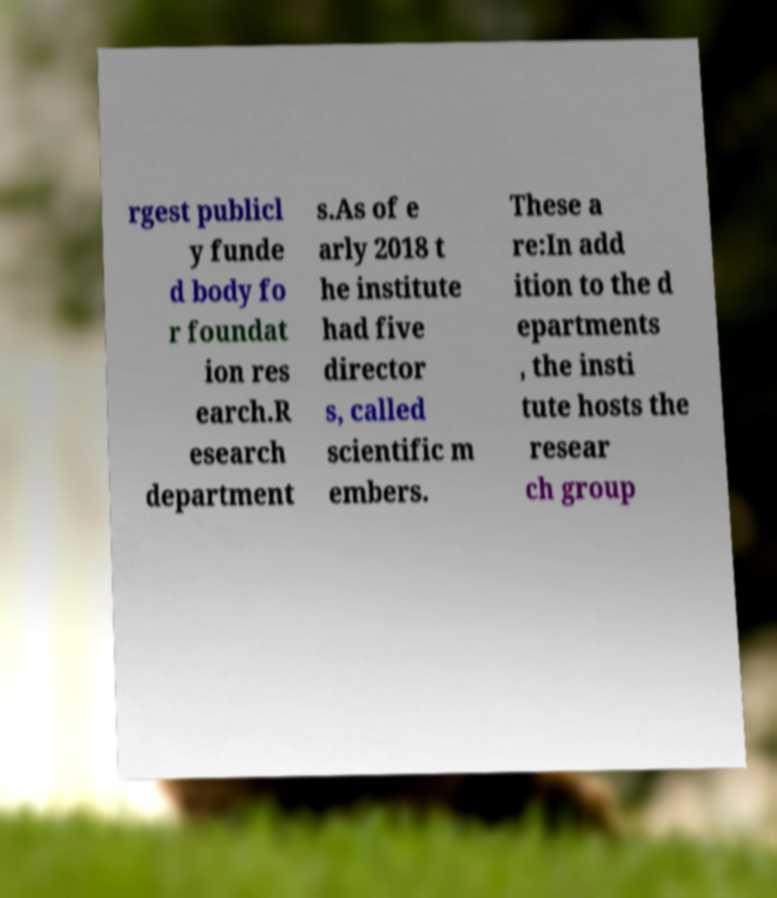For documentation purposes, I need the text within this image transcribed. Could you provide that? rgest publicl y funde d body fo r foundat ion res earch.R esearch department s.As of e arly 2018 t he institute had five director s, called scientific m embers. These a re:In add ition to the d epartments , the insti tute hosts the resear ch group 